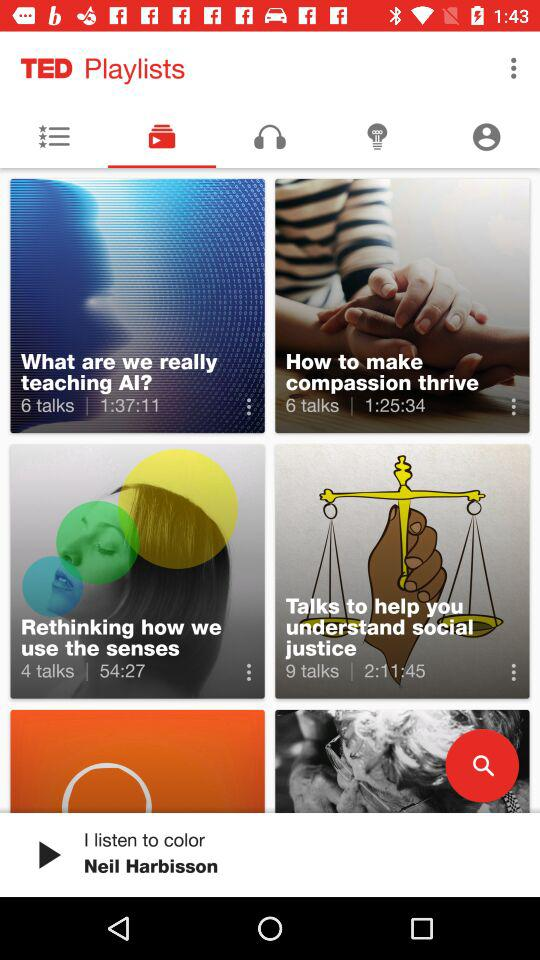How many talks are there to understand social justice? There are 9 talks. 